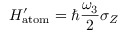<formula> <loc_0><loc_0><loc_500><loc_500>H _ { a t o m } ^ { \prime } = \hbar { } \omega _ { 3 } } { 2 } \sigma _ { Z }</formula> 